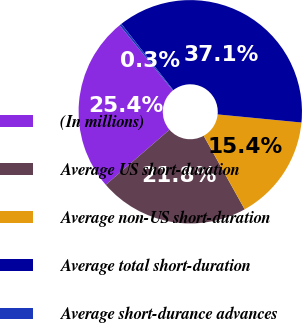Convert chart to OTSL. <chart><loc_0><loc_0><loc_500><loc_500><pie_chart><fcel>(In millions)<fcel>Average US short-duration<fcel>Average non-US short-duration<fcel>Average total short-duration<fcel>Average short-durance advances<nl><fcel>25.44%<fcel>21.75%<fcel>15.37%<fcel>37.12%<fcel>0.32%<nl></chart> 